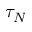Convert formula to latex. <formula><loc_0><loc_0><loc_500><loc_500>\tau _ { N }</formula> 